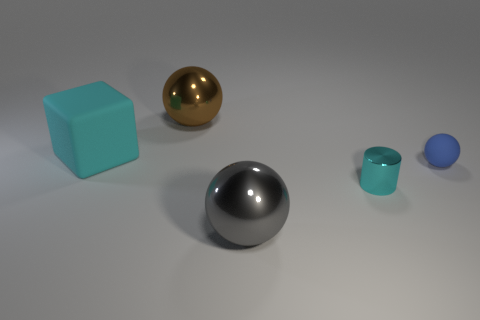Does the large matte thing have the same color as the cylinder?
Ensure brevity in your answer.  Yes. What material is the cyan object behind the blue rubber sphere?
Your answer should be compact. Rubber. Are there any other large cyan objects that have the same shape as the cyan shiny thing?
Your answer should be very brief. No. How many small blue matte objects have the same shape as the big brown object?
Ensure brevity in your answer.  1. Is the size of the thing to the right of the small cyan cylinder the same as the metal ball that is right of the big brown shiny object?
Your response must be concise. No. What shape is the thing left of the big metal thing left of the gray metallic thing?
Ensure brevity in your answer.  Cube. Are there an equal number of small balls that are left of the cyan cube and small brown matte cylinders?
Provide a short and direct response. Yes. The sphere that is right of the big shiny sphere in front of the big rubber thing left of the small cyan metallic thing is made of what material?
Your answer should be very brief. Rubber. Is there a object of the same size as the blue matte ball?
Ensure brevity in your answer.  Yes. What is the shape of the tiny matte object?
Your answer should be compact. Sphere. 